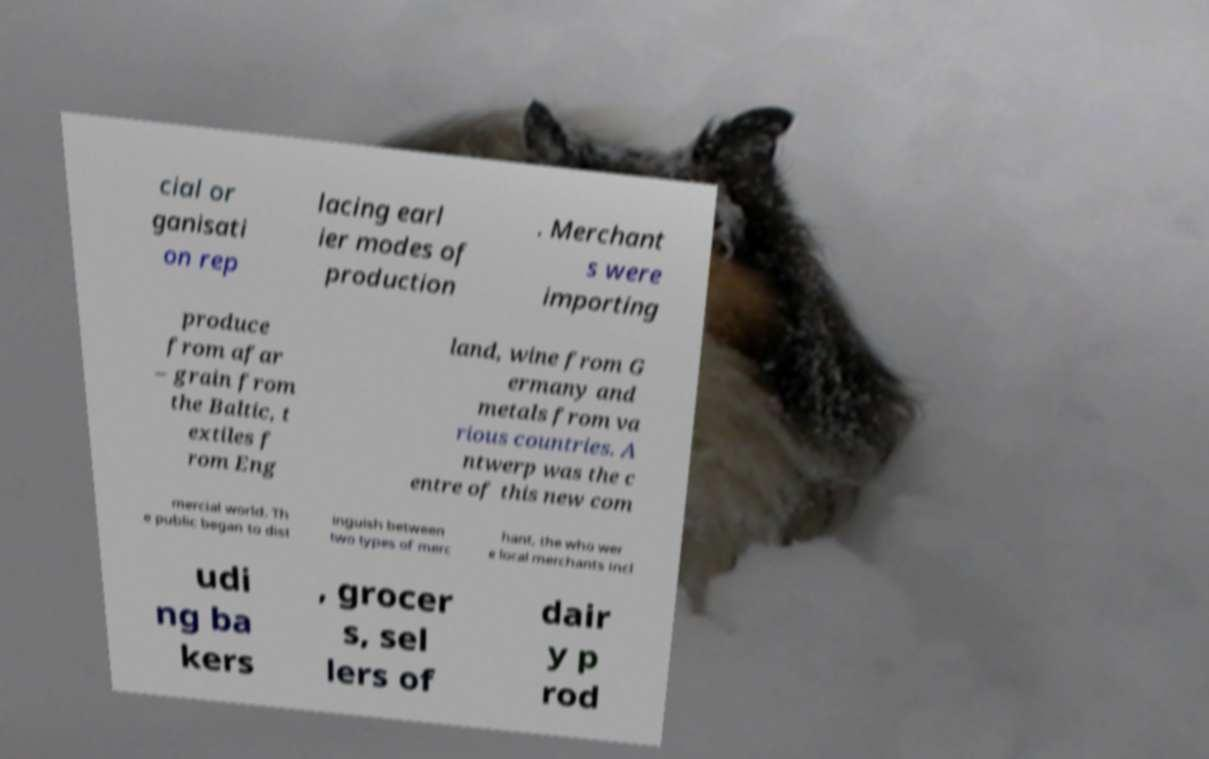Could you assist in decoding the text presented in this image and type it out clearly? cial or ganisati on rep lacing earl ier modes of production . Merchant s were importing produce from afar – grain from the Baltic, t extiles f rom Eng land, wine from G ermany and metals from va rious countries. A ntwerp was the c entre of this new com mercial world. Th e public began to dist inguish between two types of merc hant, the who wer e local merchants incl udi ng ba kers , grocer s, sel lers of dair y p rod 